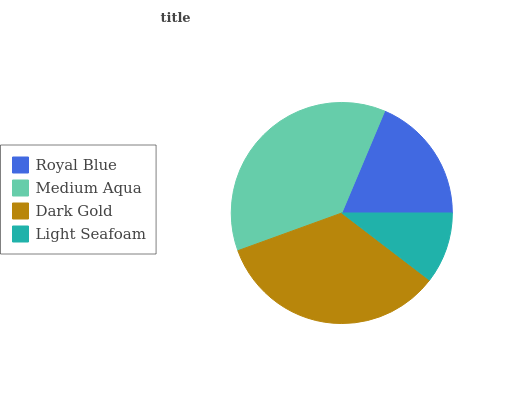Is Light Seafoam the minimum?
Answer yes or no. Yes. Is Medium Aqua the maximum?
Answer yes or no. Yes. Is Dark Gold the minimum?
Answer yes or no. No. Is Dark Gold the maximum?
Answer yes or no. No. Is Medium Aqua greater than Dark Gold?
Answer yes or no. Yes. Is Dark Gold less than Medium Aqua?
Answer yes or no. Yes. Is Dark Gold greater than Medium Aqua?
Answer yes or no. No. Is Medium Aqua less than Dark Gold?
Answer yes or no. No. Is Dark Gold the high median?
Answer yes or no. Yes. Is Royal Blue the low median?
Answer yes or no. Yes. Is Medium Aqua the high median?
Answer yes or no. No. Is Light Seafoam the low median?
Answer yes or no. No. 